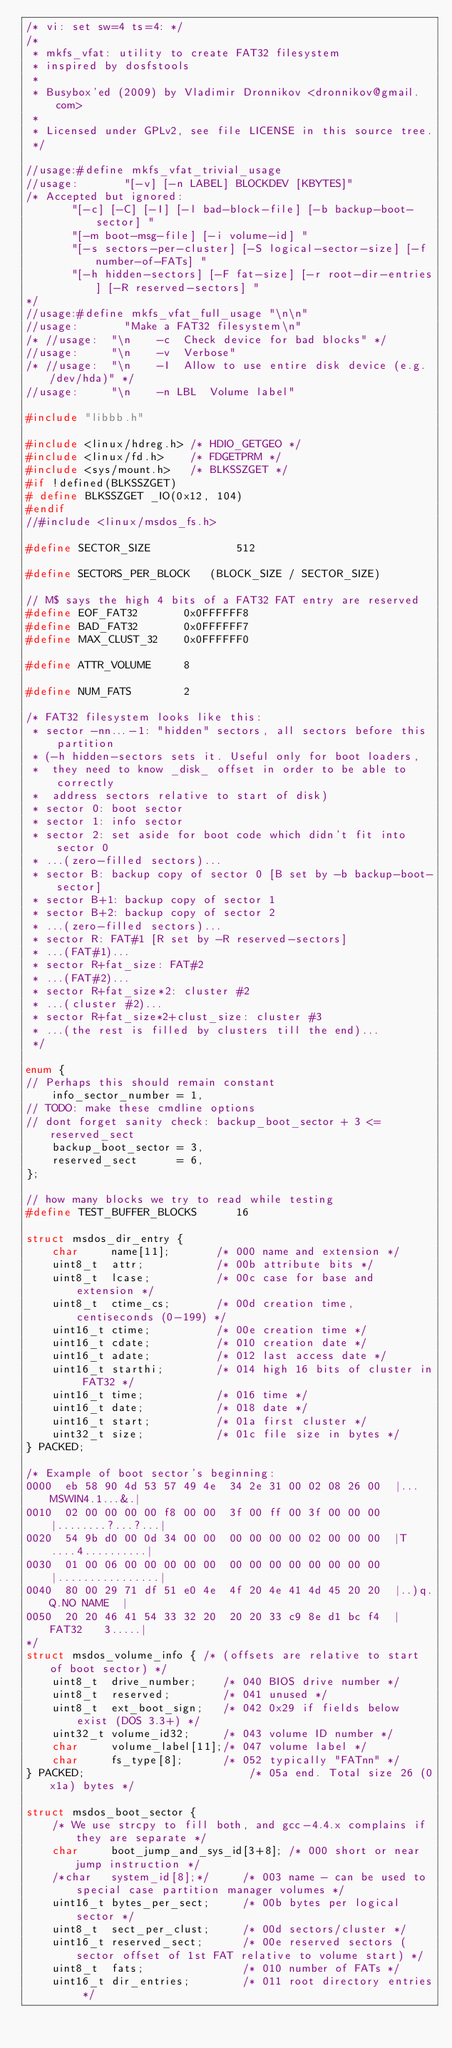<code> <loc_0><loc_0><loc_500><loc_500><_C_>/* vi: set sw=4 ts=4: */
/*
 * mkfs_vfat: utility to create FAT32 filesystem
 * inspired by dosfstools
 *
 * Busybox'ed (2009) by Vladimir Dronnikov <dronnikov@gmail.com>
 *
 * Licensed under GPLv2, see file LICENSE in this source tree.
 */

//usage:#define mkfs_vfat_trivial_usage
//usage:       "[-v] [-n LABEL] BLOCKDEV [KBYTES]"
/* Accepted but ignored:
       "[-c] [-C] [-I] [-l bad-block-file] [-b backup-boot-sector] "
       "[-m boot-msg-file] [-i volume-id] "
       "[-s sectors-per-cluster] [-S logical-sector-size] [-f number-of-FATs] "
       "[-h hidden-sectors] [-F fat-size] [-r root-dir-entries] [-R reserved-sectors] "
*/
//usage:#define mkfs_vfat_full_usage "\n\n"
//usage:       "Make a FAT32 filesystem\n"
/* //usage:  "\n	-c	Check device for bad blocks" */
//usage:     "\n	-v	Verbose"
/* //usage:  "\n	-I	Allow to use entire disk device (e.g. /dev/hda)" */
//usage:     "\n	-n LBL	Volume label"

#include "libbb.h"

#include <linux/hdreg.h> /* HDIO_GETGEO */
#include <linux/fd.h>    /* FDGETPRM */
#include <sys/mount.h>   /* BLKSSZGET */
#if !defined(BLKSSZGET)
# define BLKSSZGET _IO(0x12, 104)
#endif
//#include <linux/msdos_fs.h>

#define SECTOR_SIZE             512

#define SECTORS_PER_BLOCK	(BLOCK_SIZE / SECTOR_SIZE)

// M$ says the high 4 bits of a FAT32 FAT entry are reserved
#define EOF_FAT32       0x0FFFFFF8
#define BAD_FAT32       0x0FFFFFF7
#define MAX_CLUST_32    0x0FFFFFF0

#define ATTR_VOLUME     8

#define NUM_FATS        2

/* FAT32 filesystem looks like this:
 * sector -nn...-1: "hidden" sectors, all sectors before this partition
 * (-h hidden-sectors sets it. Useful only for boot loaders,
 *  they need to know _disk_ offset in order to be able to correctly
 *  address sectors relative to start of disk)
 * sector 0: boot sector
 * sector 1: info sector
 * sector 2: set aside for boot code which didn't fit into sector 0
 * ...(zero-filled sectors)...
 * sector B: backup copy of sector 0 [B set by -b backup-boot-sector]
 * sector B+1: backup copy of sector 1
 * sector B+2: backup copy of sector 2
 * ...(zero-filled sectors)...
 * sector R: FAT#1 [R set by -R reserved-sectors]
 * ...(FAT#1)...
 * sector R+fat_size: FAT#2
 * ...(FAT#2)...
 * sector R+fat_size*2: cluster #2
 * ...(cluster #2)...
 * sector R+fat_size*2+clust_size: cluster #3
 * ...(the rest is filled by clusters till the end)...
 */

enum {
// Perhaps this should remain constant
	info_sector_number = 1,
// TODO: make these cmdline options
// dont forget sanity check: backup_boot_sector + 3 <= reserved_sect
	backup_boot_sector = 3,
	reserved_sect      = 6,
};

// how many blocks we try to read while testing
#define TEST_BUFFER_BLOCKS      16

struct msdos_dir_entry {
	char     name[11];       /* 000 name and extension */
	uint8_t  attr;           /* 00b attribute bits */
	uint8_t  lcase;          /* 00c case for base and extension */
	uint8_t  ctime_cs;       /* 00d creation time, centiseconds (0-199) */
	uint16_t ctime;          /* 00e creation time */
	uint16_t cdate;          /* 010 creation date */
	uint16_t adate;          /* 012 last access date */
	uint16_t starthi;        /* 014 high 16 bits of cluster in FAT32 */
	uint16_t time;           /* 016 time */
	uint16_t date;           /* 018 date */
	uint16_t start;          /* 01a first cluster */
	uint32_t size;           /* 01c file size in bytes */
} PACKED;

/* Example of boot sector's beginning:
0000  eb 58 90 4d 53 57 49 4e  34 2e 31 00 02 08 26 00  |...MSWIN4.1...&.|
0010  02 00 00 00 00 f8 00 00  3f 00 ff 00 3f 00 00 00  |........?...?...|
0020  54 9b d0 00 0d 34 00 00  00 00 00 00 02 00 00 00  |T....4..........|
0030  01 00 06 00 00 00 00 00  00 00 00 00 00 00 00 00  |................|
0040  80 00 29 71 df 51 e0 4e  4f 20 4e 41 4d 45 20 20  |..)q.Q.NO NAME  |
0050  20 20 46 41 54 33 32 20  20 20 33 c9 8e d1 bc f4  |  FAT32   3.....|
*/
struct msdos_volume_info { /* (offsets are relative to start of boot sector) */
	uint8_t  drive_number;    /* 040 BIOS drive number */
	uint8_t  reserved;        /* 041 unused */
	uint8_t  ext_boot_sign;	  /* 042 0x29 if fields below exist (DOS 3.3+) */
	uint32_t volume_id32;     /* 043 volume ID number */
	char     volume_label[11];/* 047 volume label */
	char     fs_type[8];      /* 052 typically "FATnn" */
} PACKED;                         /* 05a end. Total size 26 (0x1a) bytes */

struct msdos_boot_sector {
	/* We use strcpy to fill both, and gcc-4.4.x complains if they are separate */
	char     boot_jump_and_sys_id[3+8]; /* 000 short or near jump instruction */
	/*char   system_id[8];*/     /* 003 name - can be used to special case partition manager volumes */
	uint16_t bytes_per_sect;     /* 00b bytes per logical sector */
	uint8_t  sect_per_clust;     /* 00d sectors/cluster */
	uint16_t reserved_sect;      /* 00e reserved sectors (sector offset of 1st FAT relative to volume start) */
	uint8_t  fats;               /* 010 number of FATs */
	uint16_t dir_entries;        /* 011 root directory entries */</code> 